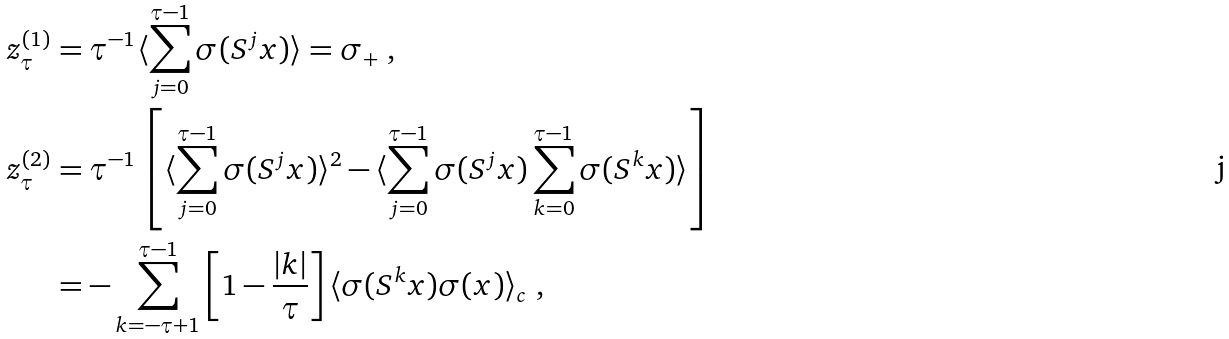Convert formula to latex. <formula><loc_0><loc_0><loc_500><loc_500>z ^ { ( 1 ) } _ { \tau } & = \tau ^ { - 1 } \langle \sum _ { j = 0 } ^ { \tau - 1 } \sigma ( S ^ { j } x ) \rangle = \sigma _ { + } \ , \\ z ^ { ( 2 ) } _ { \tau } & = \tau ^ { - 1 } \left [ \langle \sum _ { j = 0 } ^ { \tau - 1 } \sigma ( S ^ { j } x ) \rangle ^ { 2 } - \langle \sum _ { j = 0 } ^ { \tau - 1 } \sigma ( S ^ { j } x ) \sum _ { k = 0 } ^ { \tau - 1 } \sigma ( S ^ { k } x ) \rangle \right ] \\ & = - \sum _ { k = - \tau + 1 } ^ { \tau - 1 } \left [ 1 - \frac { | k | } { \tau } \right ] \langle \sigma ( S ^ { k } x ) \sigma ( x ) \rangle _ { c } \ ,</formula> 